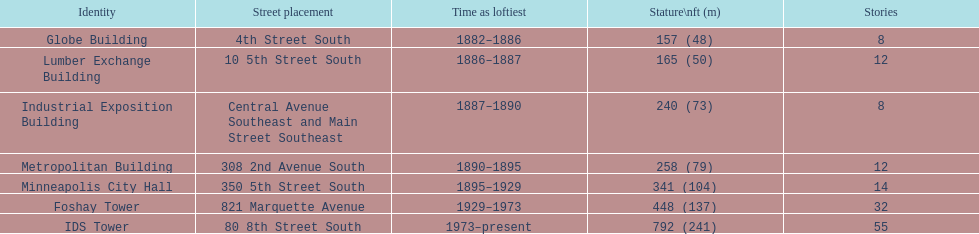After ids tower what is the second tallest building in minneapolis? Foshay Tower. 